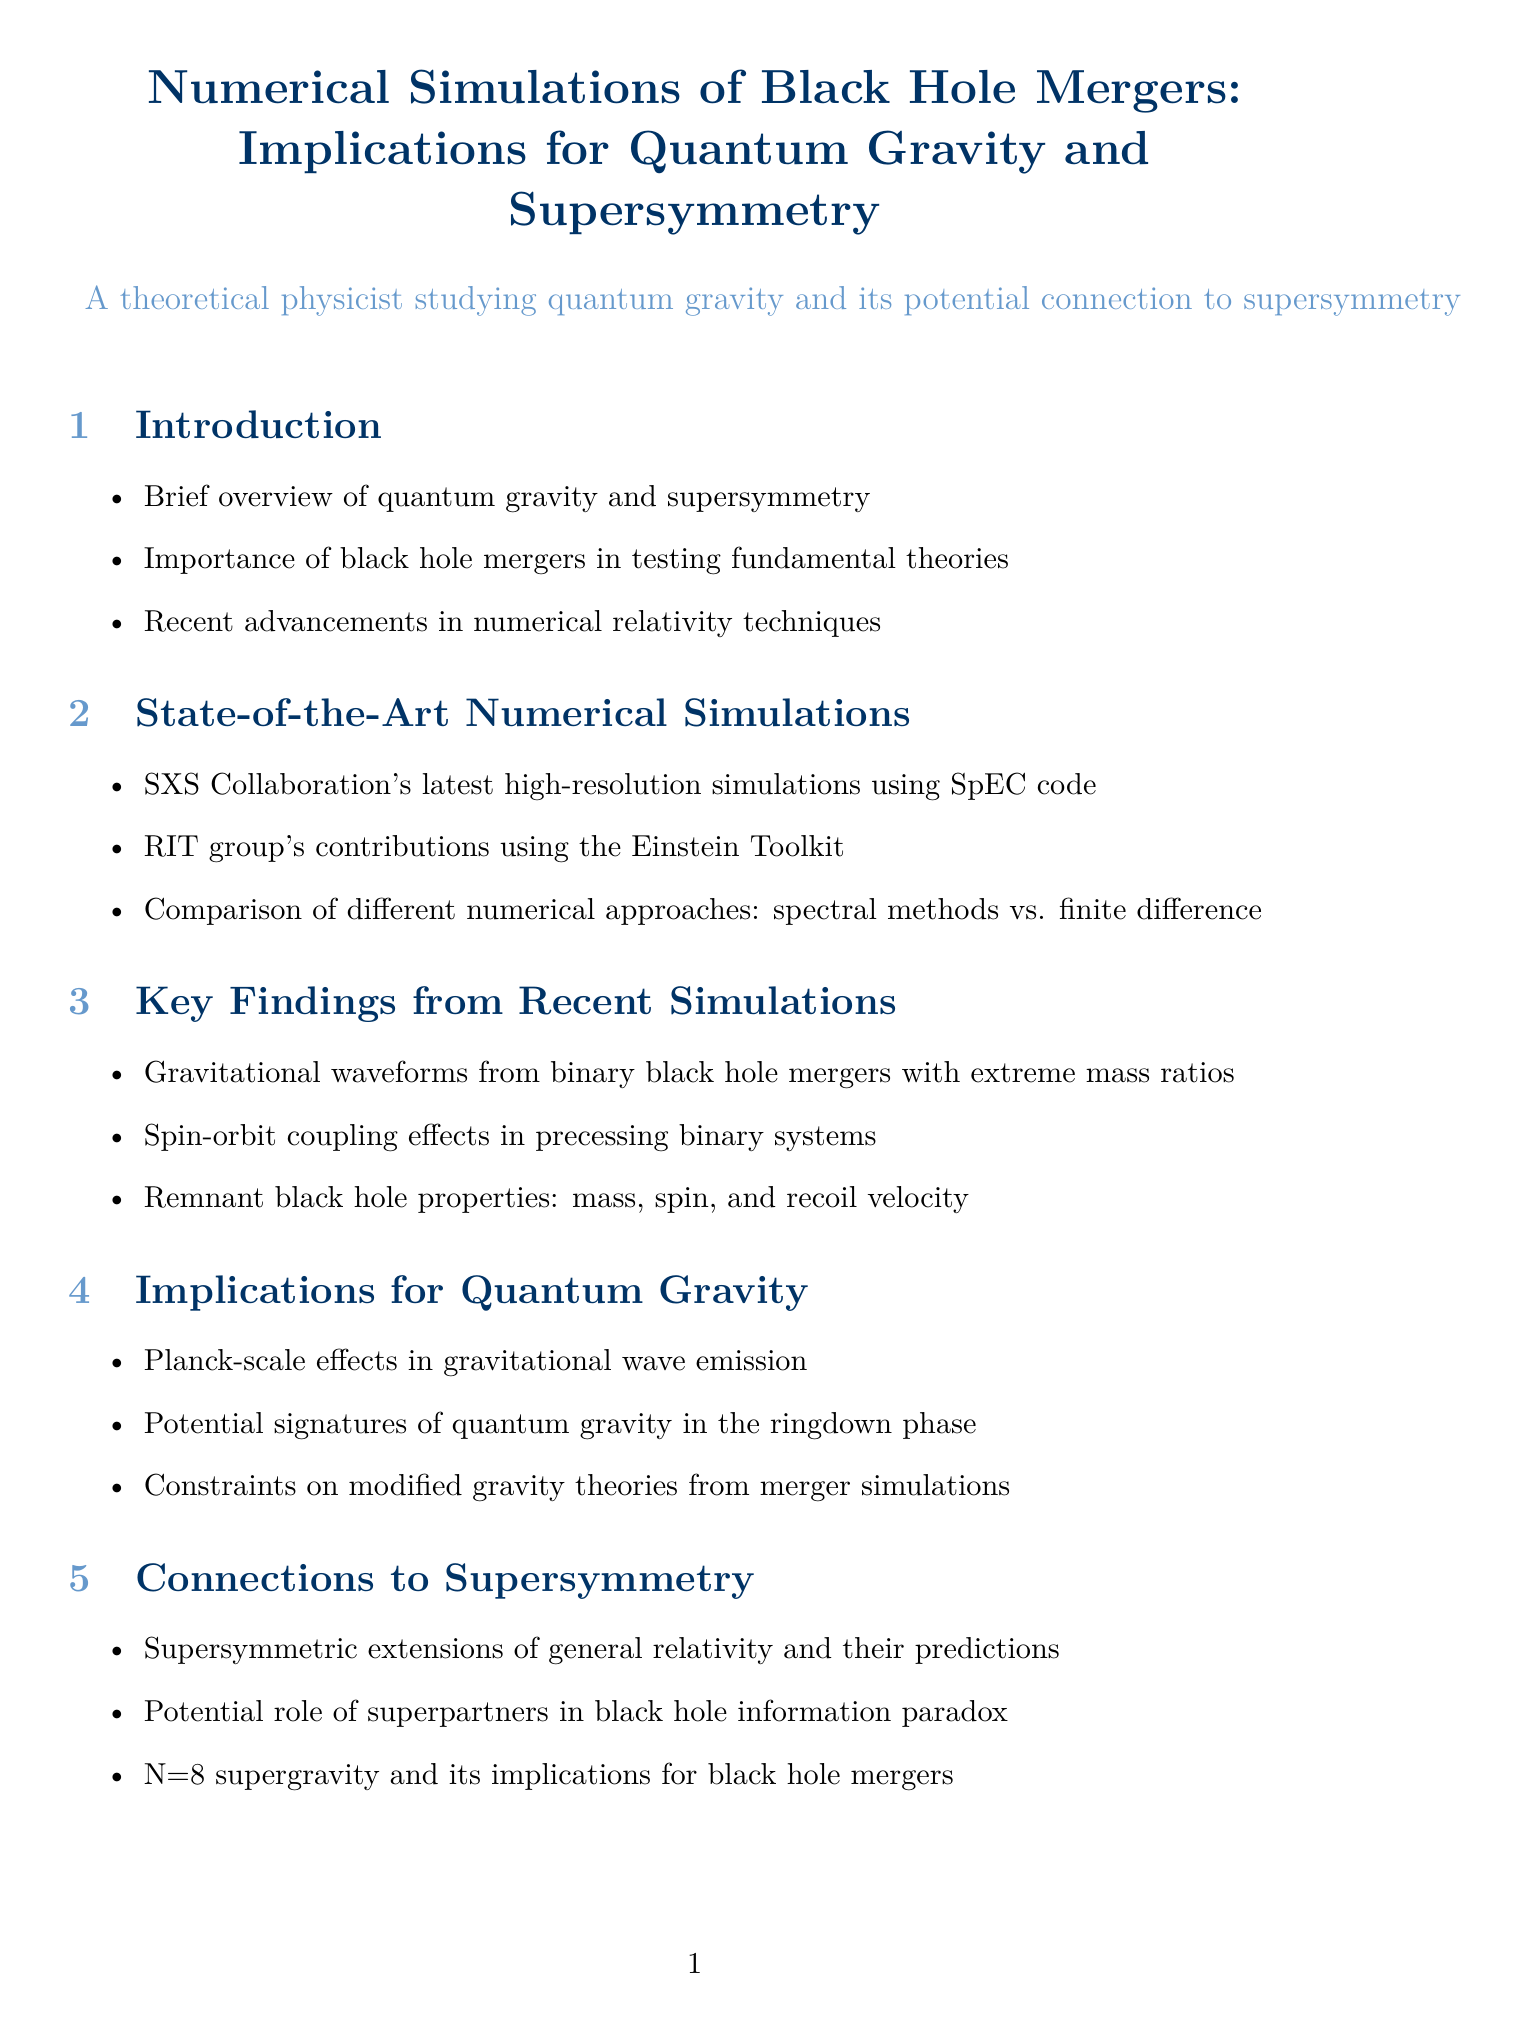What is the title of the report? The title of the report is stated at the beginning of the document.
Answer: Numerical Simulations of Black Hole Mergers: Implications for Quantum Gravity and Supersymmetry Who is a leading expert in numerical relativity? The document lists key researchers and their contributions, including Saul Teukolsky.
Answer: Saul Teukolsky What is the main focus of the section titled "Implications for Quantum Gravity"? This section discusses how recent findings from simulations influence our understanding of quantum gravity.
Answer: Planck-scale effects in gravitational wave emission Which numerical tool is developed by an open-source community? The document lists numerical tools and their developers, including the Einstein Toolkit.
Answer: Einstein Toolkit In what year was the paper by Abdul H. Mroué published? The relevant papers section provides publication years for each paper, including Mroué's work from 2013.
Answer: 2013 What are the potential roles of superpartners mentioned in the report? The document discusses the potential role of superpartners in the context of the black hole information paradox.
Answer: Black hole information paradox Which section discusses future challenges in simulations? The "Challenges and Future Directions" section addresses limitations and needs in simulations.
Answer: Challenges and Future Directions What specific advancements have been made in numerical relativity techniques? The introduction provides insights into improvements made in numerical relativity.
Answer: Recent advancements in numerical relativity techniques 